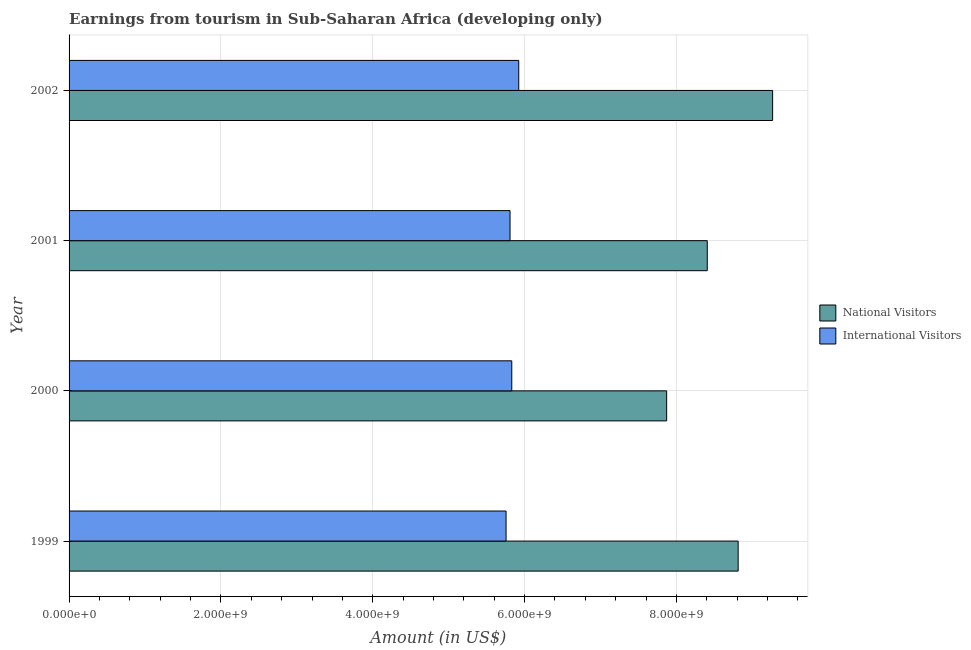How many different coloured bars are there?
Make the answer very short. 2. What is the amount earned from national visitors in 1999?
Provide a succinct answer. 8.81e+09. Across all years, what is the maximum amount earned from national visitors?
Ensure brevity in your answer.  9.27e+09. Across all years, what is the minimum amount earned from national visitors?
Provide a succinct answer. 7.87e+09. In which year was the amount earned from international visitors minimum?
Offer a terse response. 1999. What is the total amount earned from international visitors in the graph?
Your response must be concise. 2.33e+1. What is the difference between the amount earned from national visitors in 1999 and that in 2001?
Your response must be concise. 4.07e+08. What is the difference between the amount earned from international visitors in 2001 and the amount earned from national visitors in 2000?
Keep it short and to the point. -2.06e+09. What is the average amount earned from international visitors per year?
Ensure brevity in your answer.  5.83e+09. In the year 2000, what is the difference between the amount earned from national visitors and amount earned from international visitors?
Your response must be concise. 2.04e+09. In how many years, is the amount earned from national visitors greater than 3200000000 US$?
Offer a very short reply. 4. What is the difference between the highest and the second highest amount earned from national visitors?
Provide a short and direct response. 4.54e+08. What is the difference between the highest and the lowest amount earned from international visitors?
Offer a terse response. 1.67e+08. In how many years, is the amount earned from national visitors greater than the average amount earned from national visitors taken over all years?
Your answer should be very brief. 2. What does the 2nd bar from the top in 2001 represents?
Your response must be concise. National Visitors. What does the 1st bar from the bottom in 2000 represents?
Offer a very short reply. National Visitors. Are all the bars in the graph horizontal?
Provide a succinct answer. Yes. Are the values on the major ticks of X-axis written in scientific E-notation?
Give a very brief answer. Yes. Does the graph contain any zero values?
Provide a short and direct response. No. Does the graph contain grids?
Provide a short and direct response. Yes. How many legend labels are there?
Your answer should be compact. 2. What is the title of the graph?
Offer a very short reply. Earnings from tourism in Sub-Saharan Africa (developing only). What is the label or title of the X-axis?
Your response must be concise. Amount (in US$). What is the label or title of the Y-axis?
Your response must be concise. Year. What is the Amount (in US$) of National Visitors in 1999?
Your answer should be very brief. 8.81e+09. What is the Amount (in US$) of International Visitors in 1999?
Your answer should be very brief. 5.76e+09. What is the Amount (in US$) of National Visitors in 2000?
Offer a very short reply. 7.87e+09. What is the Amount (in US$) in International Visitors in 2000?
Your answer should be compact. 5.83e+09. What is the Amount (in US$) of National Visitors in 2001?
Offer a terse response. 8.41e+09. What is the Amount (in US$) of International Visitors in 2001?
Your answer should be very brief. 5.81e+09. What is the Amount (in US$) of National Visitors in 2002?
Ensure brevity in your answer.  9.27e+09. What is the Amount (in US$) in International Visitors in 2002?
Make the answer very short. 5.92e+09. Across all years, what is the maximum Amount (in US$) in National Visitors?
Provide a succinct answer. 9.27e+09. Across all years, what is the maximum Amount (in US$) of International Visitors?
Provide a short and direct response. 5.92e+09. Across all years, what is the minimum Amount (in US$) in National Visitors?
Your answer should be compact. 7.87e+09. Across all years, what is the minimum Amount (in US$) of International Visitors?
Ensure brevity in your answer.  5.76e+09. What is the total Amount (in US$) in National Visitors in the graph?
Make the answer very short. 3.44e+1. What is the total Amount (in US$) in International Visitors in the graph?
Provide a short and direct response. 2.33e+1. What is the difference between the Amount (in US$) of National Visitors in 1999 and that in 2000?
Make the answer very short. 9.42e+08. What is the difference between the Amount (in US$) of International Visitors in 1999 and that in 2000?
Offer a terse response. -7.52e+07. What is the difference between the Amount (in US$) of National Visitors in 1999 and that in 2001?
Give a very brief answer. 4.07e+08. What is the difference between the Amount (in US$) in International Visitors in 1999 and that in 2001?
Offer a terse response. -5.22e+07. What is the difference between the Amount (in US$) in National Visitors in 1999 and that in 2002?
Ensure brevity in your answer.  -4.54e+08. What is the difference between the Amount (in US$) of International Visitors in 1999 and that in 2002?
Keep it short and to the point. -1.67e+08. What is the difference between the Amount (in US$) in National Visitors in 2000 and that in 2001?
Your response must be concise. -5.35e+08. What is the difference between the Amount (in US$) in International Visitors in 2000 and that in 2001?
Provide a short and direct response. 2.30e+07. What is the difference between the Amount (in US$) in National Visitors in 2000 and that in 2002?
Make the answer very short. -1.40e+09. What is the difference between the Amount (in US$) of International Visitors in 2000 and that in 2002?
Give a very brief answer. -9.17e+07. What is the difference between the Amount (in US$) of National Visitors in 2001 and that in 2002?
Offer a very short reply. -8.61e+08. What is the difference between the Amount (in US$) in International Visitors in 2001 and that in 2002?
Offer a terse response. -1.15e+08. What is the difference between the Amount (in US$) of National Visitors in 1999 and the Amount (in US$) of International Visitors in 2000?
Offer a very short reply. 2.98e+09. What is the difference between the Amount (in US$) in National Visitors in 1999 and the Amount (in US$) in International Visitors in 2001?
Provide a short and direct response. 3.00e+09. What is the difference between the Amount (in US$) in National Visitors in 1999 and the Amount (in US$) in International Visitors in 2002?
Give a very brief answer. 2.89e+09. What is the difference between the Amount (in US$) of National Visitors in 2000 and the Amount (in US$) of International Visitors in 2001?
Your answer should be very brief. 2.06e+09. What is the difference between the Amount (in US$) in National Visitors in 2000 and the Amount (in US$) in International Visitors in 2002?
Offer a very short reply. 1.95e+09. What is the difference between the Amount (in US$) of National Visitors in 2001 and the Amount (in US$) of International Visitors in 2002?
Ensure brevity in your answer.  2.48e+09. What is the average Amount (in US$) in National Visitors per year?
Give a very brief answer. 8.59e+09. What is the average Amount (in US$) of International Visitors per year?
Make the answer very short. 5.83e+09. In the year 1999, what is the difference between the Amount (in US$) of National Visitors and Amount (in US$) of International Visitors?
Give a very brief answer. 3.06e+09. In the year 2000, what is the difference between the Amount (in US$) of National Visitors and Amount (in US$) of International Visitors?
Provide a succinct answer. 2.04e+09. In the year 2001, what is the difference between the Amount (in US$) of National Visitors and Amount (in US$) of International Visitors?
Provide a short and direct response. 2.60e+09. In the year 2002, what is the difference between the Amount (in US$) in National Visitors and Amount (in US$) in International Visitors?
Offer a very short reply. 3.34e+09. What is the ratio of the Amount (in US$) of National Visitors in 1999 to that in 2000?
Offer a terse response. 1.12. What is the ratio of the Amount (in US$) of International Visitors in 1999 to that in 2000?
Your response must be concise. 0.99. What is the ratio of the Amount (in US$) of National Visitors in 1999 to that in 2001?
Offer a terse response. 1.05. What is the ratio of the Amount (in US$) in National Visitors in 1999 to that in 2002?
Ensure brevity in your answer.  0.95. What is the ratio of the Amount (in US$) of International Visitors in 1999 to that in 2002?
Offer a very short reply. 0.97. What is the ratio of the Amount (in US$) of National Visitors in 2000 to that in 2001?
Your response must be concise. 0.94. What is the ratio of the Amount (in US$) in National Visitors in 2000 to that in 2002?
Keep it short and to the point. 0.85. What is the ratio of the Amount (in US$) in International Visitors in 2000 to that in 2002?
Provide a short and direct response. 0.98. What is the ratio of the Amount (in US$) in National Visitors in 2001 to that in 2002?
Your response must be concise. 0.91. What is the ratio of the Amount (in US$) of International Visitors in 2001 to that in 2002?
Provide a succinct answer. 0.98. What is the difference between the highest and the second highest Amount (in US$) of National Visitors?
Offer a terse response. 4.54e+08. What is the difference between the highest and the second highest Amount (in US$) of International Visitors?
Keep it short and to the point. 9.17e+07. What is the difference between the highest and the lowest Amount (in US$) of National Visitors?
Keep it short and to the point. 1.40e+09. What is the difference between the highest and the lowest Amount (in US$) of International Visitors?
Make the answer very short. 1.67e+08. 